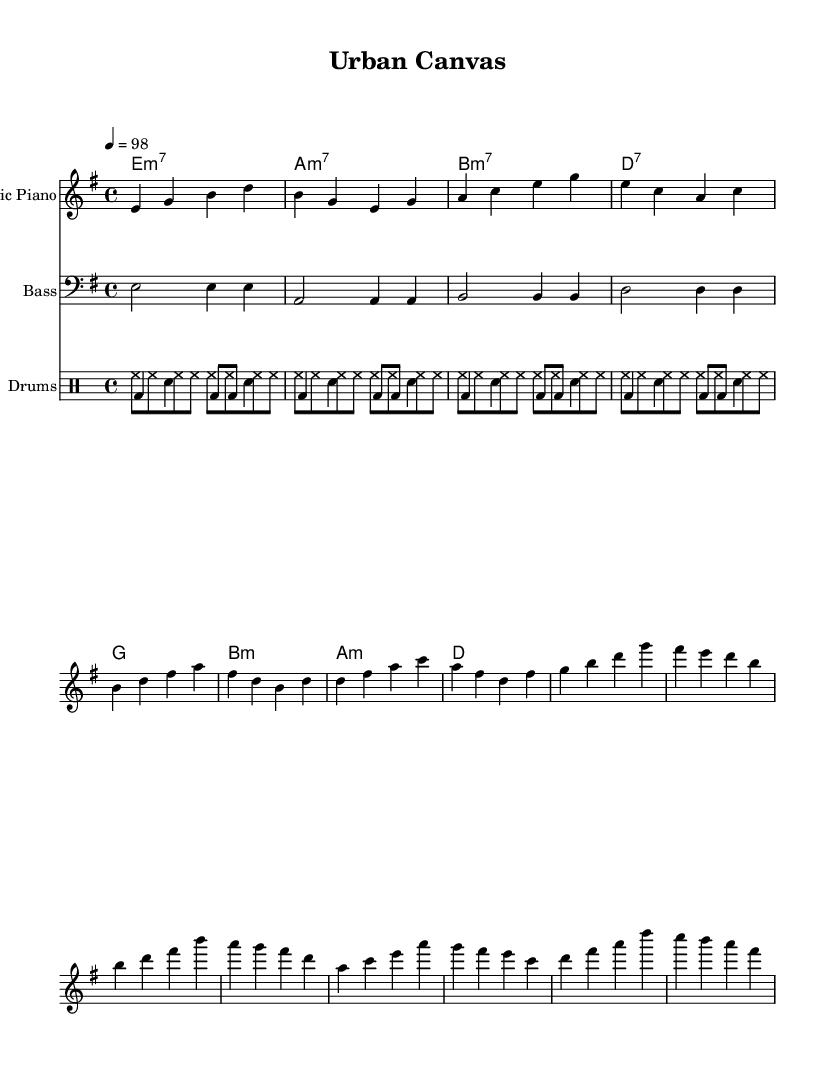What is the key signature of this music? The key signature is found at the beginning of the staff. It indicates E minor, which has one sharp (F#).
Answer: E minor What is the time signature of this music? The time signature is located at the beginning of the sheet music. It shows 4/4, meaning there are four beats in each measure and the quarter note receives one beat.
Answer: 4/4 What is the tempo marking of the music? The tempo marking is indicated by the number in beats per minute. In this case, it shows 98, which means the music should be played at 98 beats per minute.
Answer: 98 What are the main chords used in the verse section? The chords for the verse section are indicated in the chord names beneath the melody. They are E minor 7, A minor 7, B minor 7, and D7.
Answer: E minor 7, A minor 7, B minor 7, D7 How many measures are in the chorus section? To find the number of measures, we count the number of bars in the chorus melody, which has 4 measures.
Answer: 4 Which instrument plays the bass line? The bass line is indicated in the music for the staff labeled "Bass," showing that the instrument responsible for the bass is the bass guitar.
Answer: Bass guitar Identify the rhythmic pattern used by the hi-hats. The hi-hat pattern is shown in the drumming staff, which consists of consistent eighth notes throughout each measure.
Answer: Eighth notes 